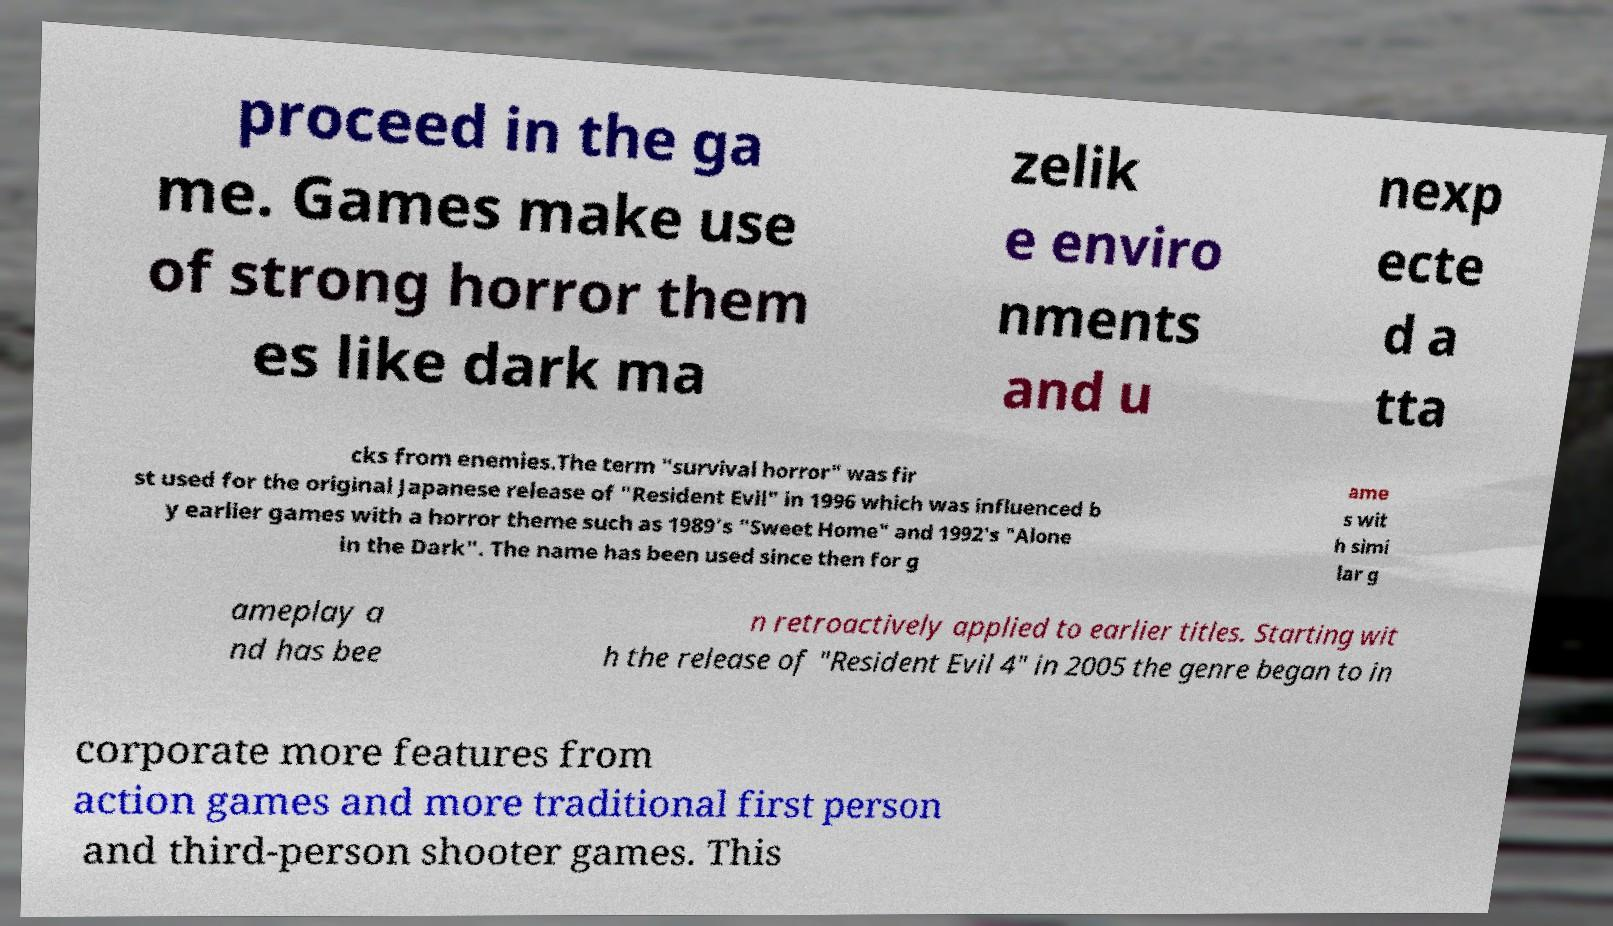There's text embedded in this image that I need extracted. Can you transcribe it verbatim? proceed in the ga me. Games make use of strong horror them es like dark ma zelik e enviro nments and u nexp ecte d a tta cks from enemies.The term "survival horror" was fir st used for the original Japanese release of "Resident Evil" in 1996 which was influenced b y earlier games with a horror theme such as 1989's "Sweet Home" and 1992's "Alone in the Dark". The name has been used since then for g ame s wit h simi lar g ameplay a nd has bee n retroactively applied to earlier titles. Starting wit h the release of "Resident Evil 4" in 2005 the genre began to in corporate more features from action games and more traditional first person and third-person shooter games. This 